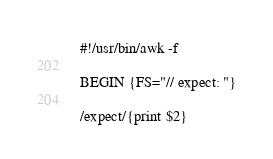Convert code to text. <code><loc_0><loc_0><loc_500><loc_500><_Awk_>#!/usr/bin/awk -f

BEGIN {FS="// expect: "}

/expect/{print $2}
</code> 